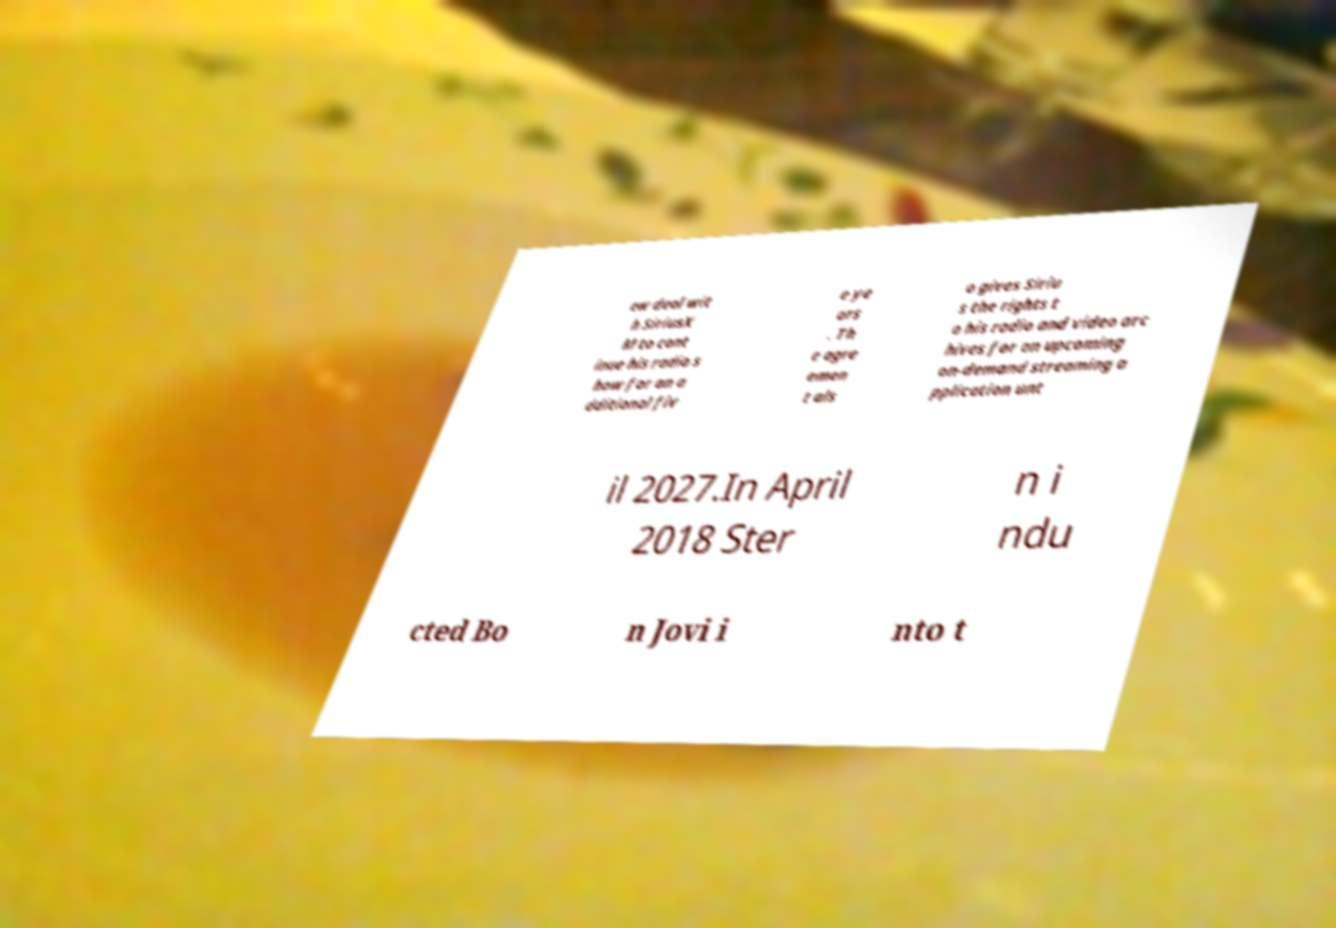What messages or text are displayed in this image? I need them in a readable, typed format. ew deal wit h SiriusX M to cont inue his radio s how for an a dditional fiv e ye ars . Th e agre emen t als o gives Siriu s the rights t o his radio and video arc hives for an upcoming on-demand streaming a pplication unt il 2027.In April 2018 Ster n i ndu cted Bo n Jovi i nto t 